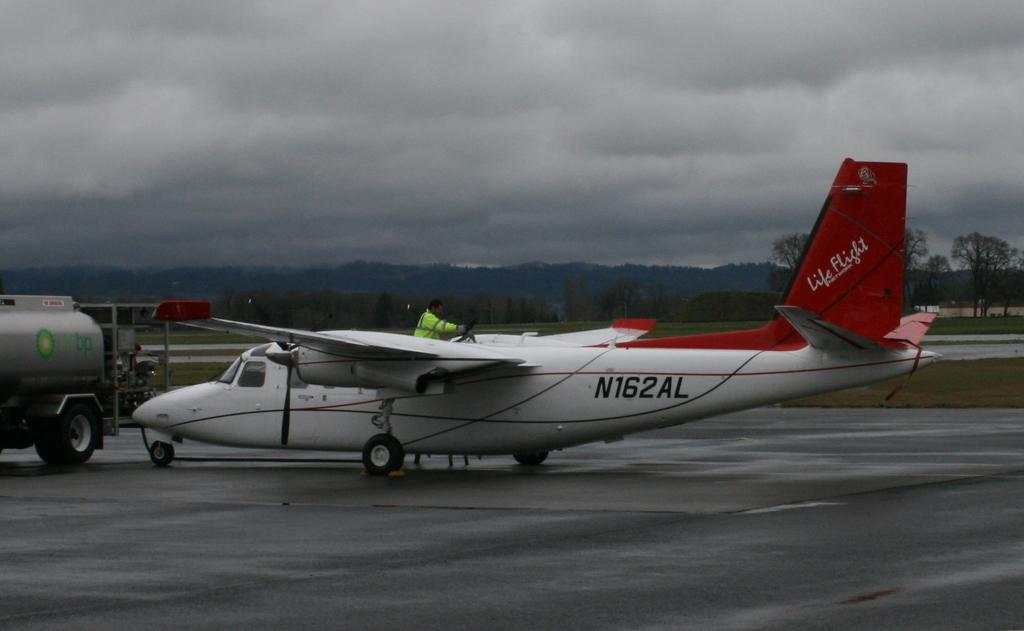<image>
Offer a succinct explanation of the picture presented. a white airplane with the identifying code of n162al 